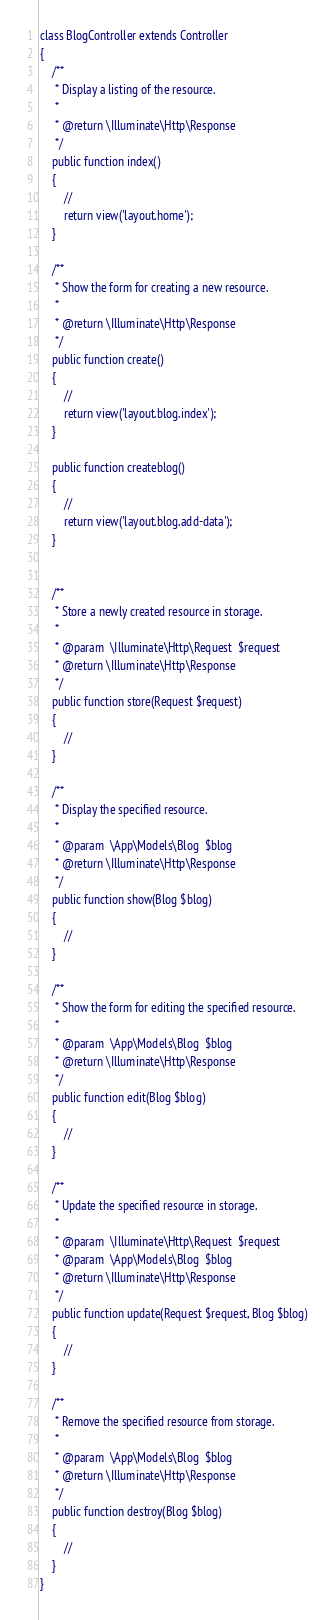<code> <loc_0><loc_0><loc_500><loc_500><_PHP_>
class BlogController extends Controller
{
    /**
     * Display a listing of the resource.
     *
     * @return \Illuminate\Http\Response
     */
    public function index()
    {
        //
        return view('layout.home');
    }

    /**
     * Show the form for creating a new resource.
     *
     * @return \Illuminate\Http\Response
     */
    public function create()
    {
        //
        return view('layout.blog.index');
    }

    public function createblog()
    {
        //
        return view('layout.blog.add-data');
    }


    /**
     * Store a newly created resource in storage.
     *
     * @param  \Illuminate\Http\Request  $request
     * @return \Illuminate\Http\Response
     */
    public function store(Request $request)
    {
        //
    }

    /**
     * Display the specified resource.
     *
     * @param  \App\Models\Blog  $blog
     * @return \Illuminate\Http\Response
     */
    public function show(Blog $blog)
    {
        //
    }

    /**
     * Show the form for editing the specified resource.
     *
     * @param  \App\Models\Blog  $blog
     * @return \Illuminate\Http\Response
     */
    public function edit(Blog $blog)
    {
        //
    }

    /**
     * Update the specified resource in storage.
     *
     * @param  \Illuminate\Http\Request  $request
     * @param  \App\Models\Blog  $blog
     * @return \Illuminate\Http\Response
     */
    public function update(Request $request, Blog $blog)
    {
        //
    }

    /**
     * Remove the specified resource from storage.
     *
     * @param  \App\Models\Blog  $blog
     * @return \Illuminate\Http\Response
     */
    public function destroy(Blog $blog)
    {
        //
    }
}
</code> 